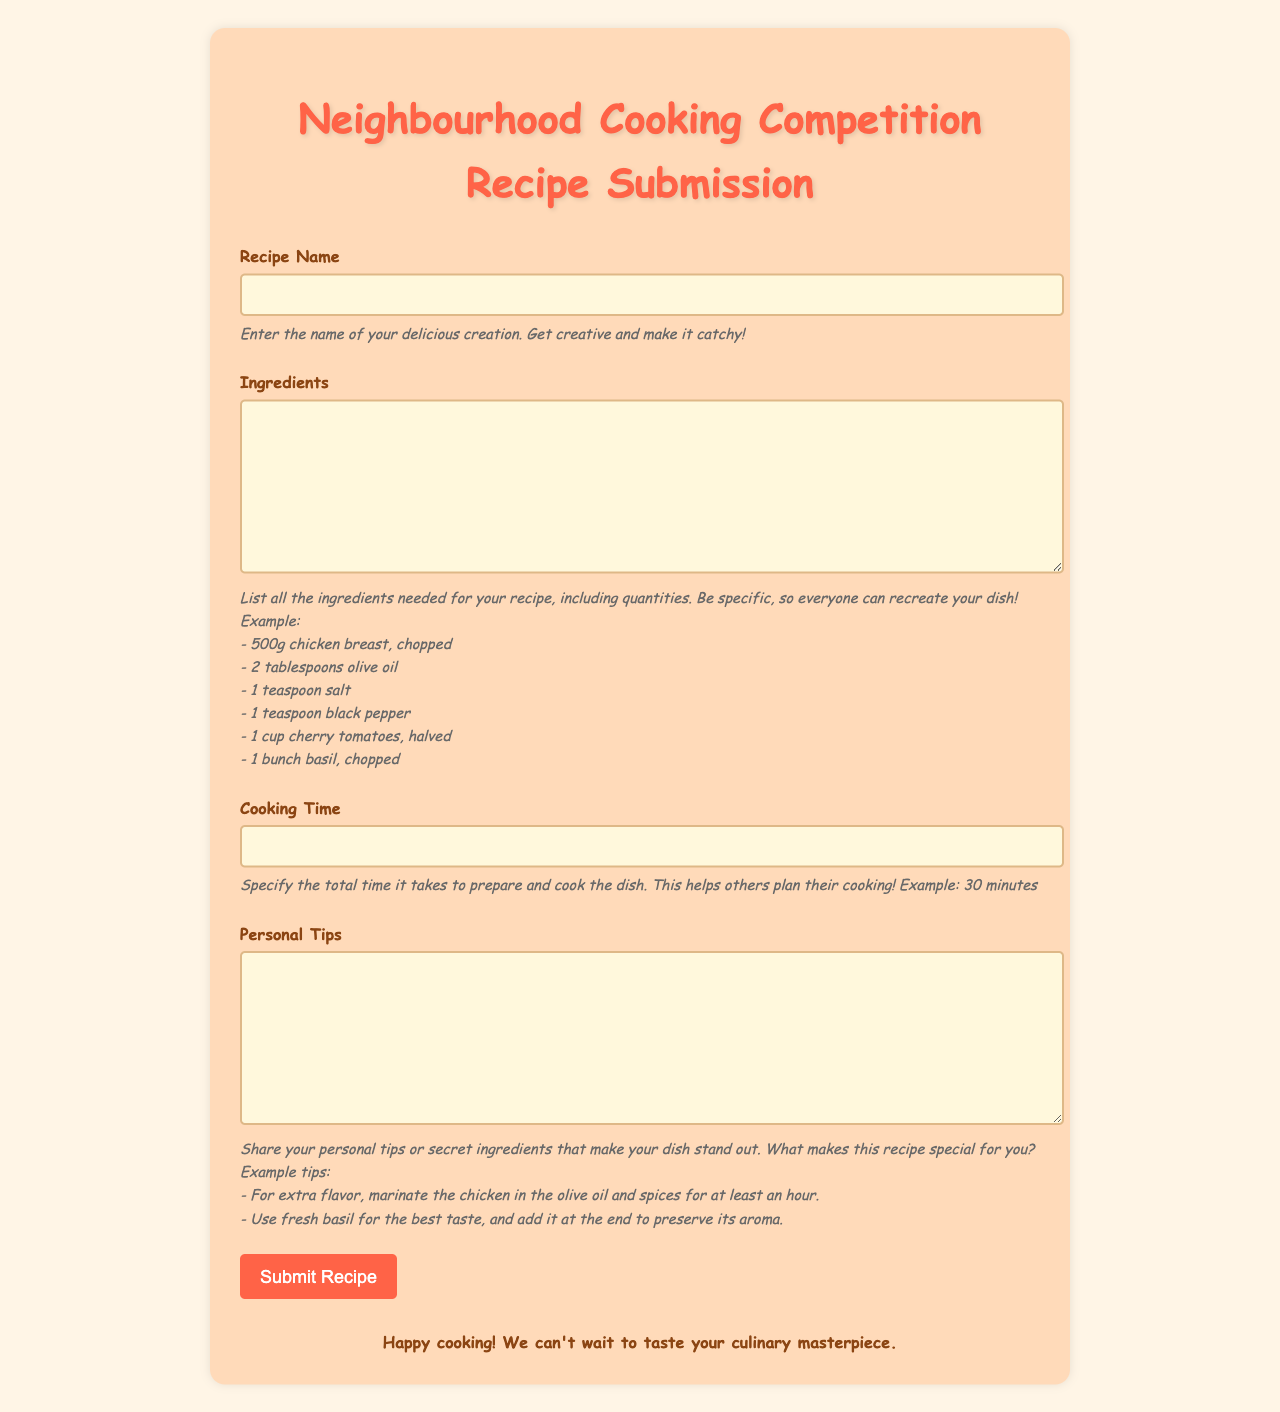what is the title of the document? The title appears prominently at the top of the form, indicating its purpose.
Answer: Neighborhood Cooking Competition Recipe Submission what are the required fields in the form? The form specifies several fields that must be completed for submission.
Answer: Recipe Name, Ingredients, Cooking Time, Personal Tips what color is the background of the form? The background color is mentioned in the style section of the document, describing the design elements.
Answer: #FFF5E6 how long can the cooking time be specified? The document encourages entrants to provide a time estimation that helps others in their cooking preparation.
Answer: Example: 30 minutes what is included in the personal tips section? The instructions for this section suggest providing useful cooking secrets and personal insights about the recipe.
Answer: Tips or secret ingredients what type of button is at the bottom of the form? This relates to the action users will take after filling out the form.
Answer: Submit Recipe button who is encouraged to participate in this competition? The greeting message suggests this audience for the competition.
Answer: Neighbors or community members what font is used throughout the document? The style section specifies the type of font for the text in the document.
Answer: Comic Sans MS what should be included in the ingredients list? The instructions emphasize the importance of clarity and detail in this section.
Answer: List all ingredients needed with quantities 